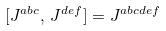Convert formula to latex. <formula><loc_0><loc_0><loc_500><loc_500>[ J ^ { a b c } , \, J ^ { d e f } ] & = J ^ { a b c d e f }</formula> 